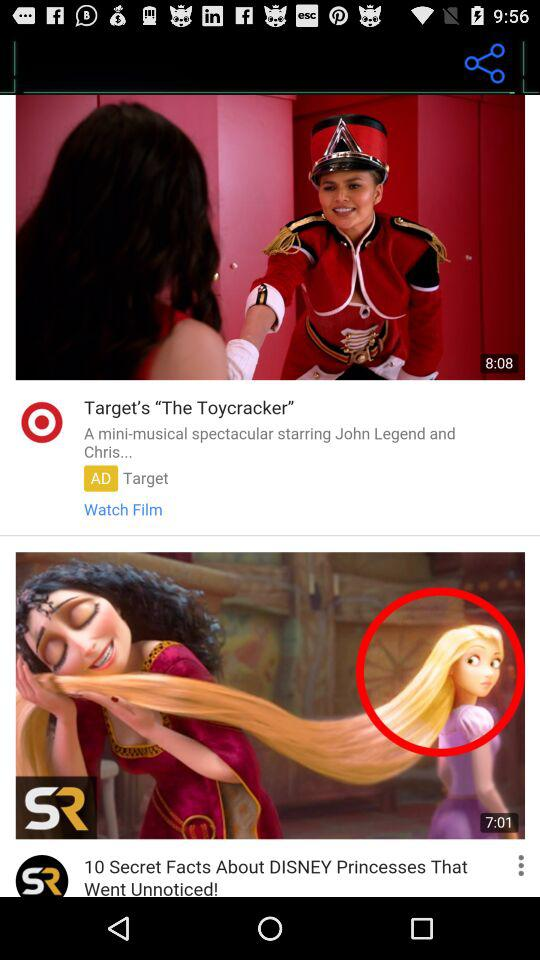What's the duration of the "10 Secret Facts About DISNEY Princesses That Went Unnoticed!" video? The duration of the "10 Secret Facts About DISNEY Princesses That Went Unnoticed!" video is 7 minutes 1 second. 